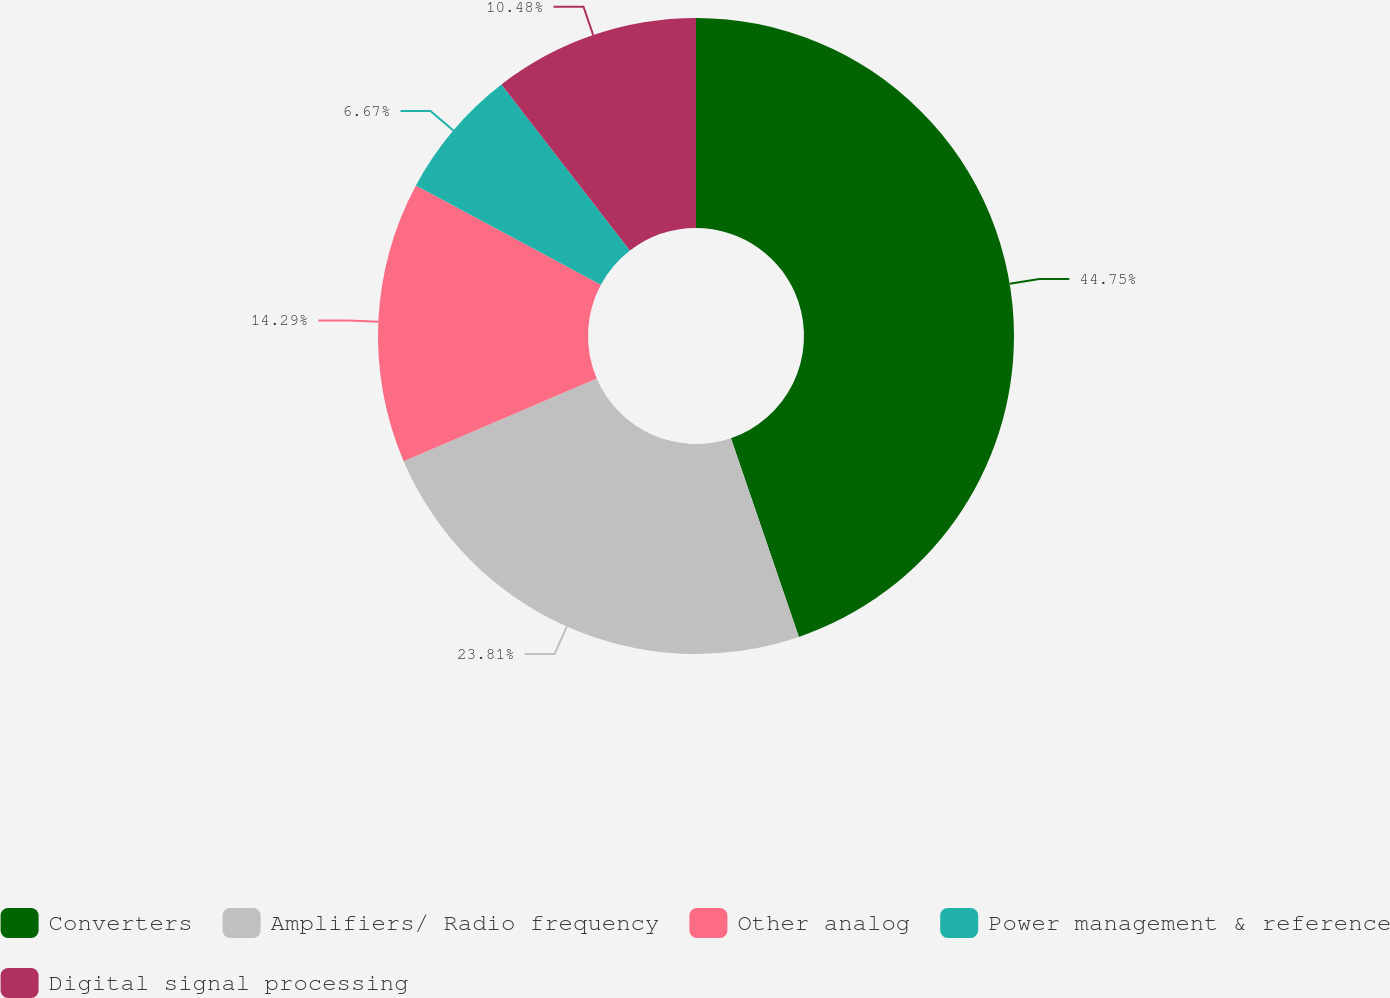Convert chart to OTSL. <chart><loc_0><loc_0><loc_500><loc_500><pie_chart><fcel>Converters<fcel>Amplifiers/ Radio frequency<fcel>Other analog<fcel>Power management & reference<fcel>Digital signal processing<nl><fcel>44.76%<fcel>23.81%<fcel>14.29%<fcel>6.67%<fcel>10.48%<nl></chart> 